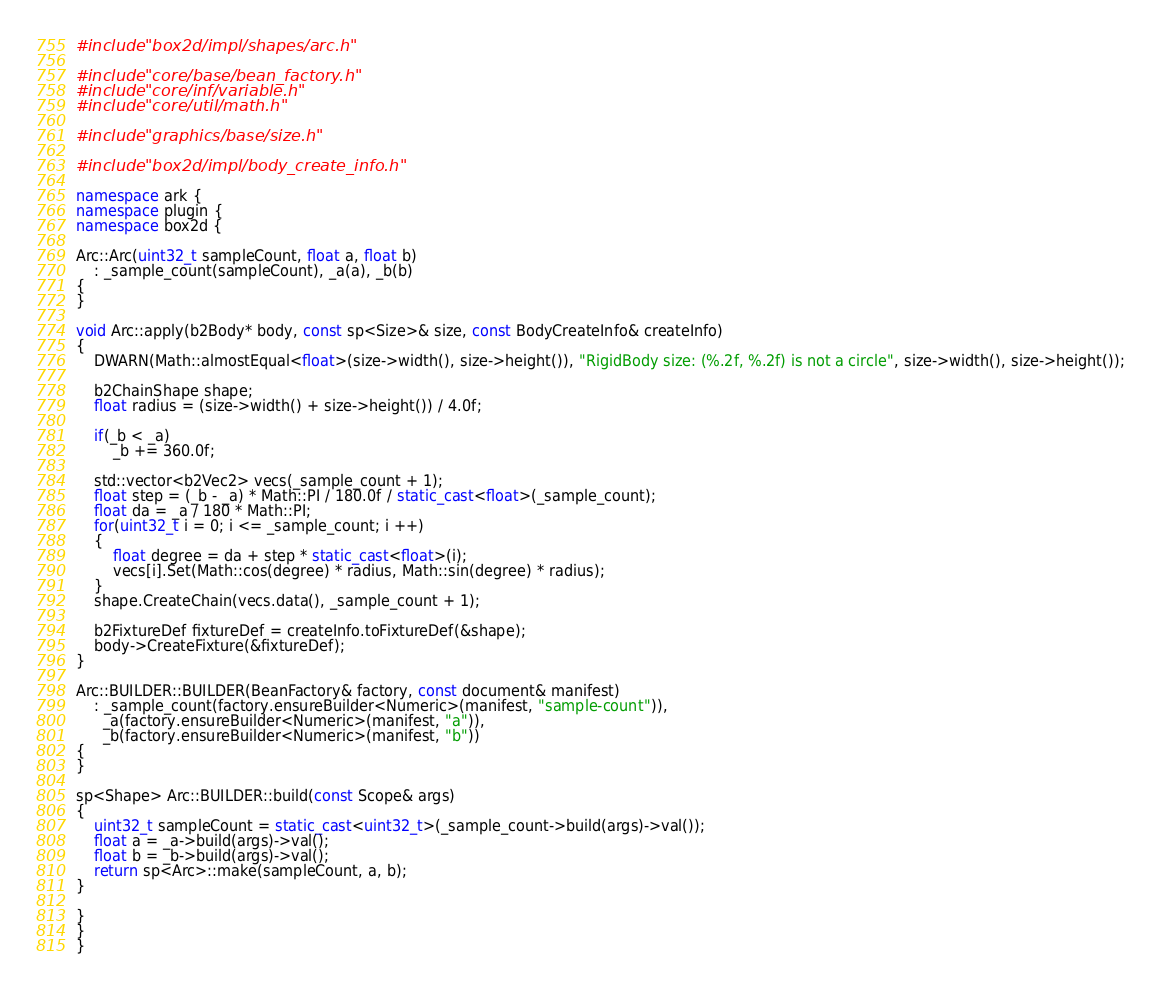Convert code to text. <code><loc_0><loc_0><loc_500><loc_500><_C++_>#include "box2d/impl/shapes/arc.h"

#include "core/base/bean_factory.h"
#include "core/inf/variable.h"
#include "core/util/math.h"

#include "graphics/base/size.h"

#include "box2d/impl/body_create_info.h"

namespace ark {
namespace plugin {
namespace box2d {

Arc::Arc(uint32_t sampleCount, float a, float b)
    : _sample_count(sampleCount), _a(a), _b(b)
{
}

void Arc::apply(b2Body* body, const sp<Size>& size, const BodyCreateInfo& createInfo)
{
    DWARN(Math::almostEqual<float>(size->width(), size->height()), "RigidBody size: (%.2f, %.2f) is not a circle", size->width(), size->height());

    b2ChainShape shape;
    float radius = (size->width() + size->height()) / 4.0f;

    if(_b < _a)
        _b += 360.0f;

    std::vector<b2Vec2> vecs(_sample_count + 1);
    float step = (_b - _a) * Math::PI / 180.0f / static_cast<float>(_sample_count);
    float da = _a / 180 * Math::PI;
    for(uint32_t i = 0; i <= _sample_count; i ++)
    {
        float degree = da + step * static_cast<float>(i);
        vecs[i].Set(Math::cos(degree) * radius, Math::sin(degree) * radius);
    }
    shape.CreateChain(vecs.data(), _sample_count + 1);

    b2FixtureDef fixtureDef = createInfo.toFixtureDef(&shape);
    body->CreateFixture(&fixtureDef);
}

Arc::BUILDER::BUILDER(BeanFactory& factory, const document& manifest)
    : _sample_count(factory.ensureBuilder<Numeric>(manifest, "sample-count")),
      _a(factory.ensureBuilder<Numeric>(manifest, "a")),
      _b(factory.ensureBuilder<Numeric>(manifest, "b"))
{
}

sp<Shape> Arc::BUILDER::build(const Scope& args)
{
    uint32_t sampleCount = static_cast<uint32_t>(_sample_count->build(args)->val());
    float a = _a->build(args)->val();
    float b = _b->build(args)->val();
    return sp<Arc>::make(sampleCount, a, b);
}

}
}
}
</code> 